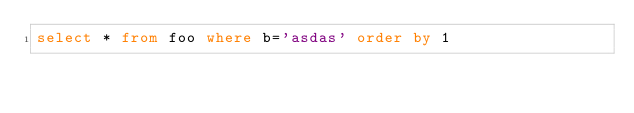Convert code to text. <code><loc_0><loc_0><loc_500><loc_500><_SQL_>select * from foo where b='asdas' order by 1
</code> 